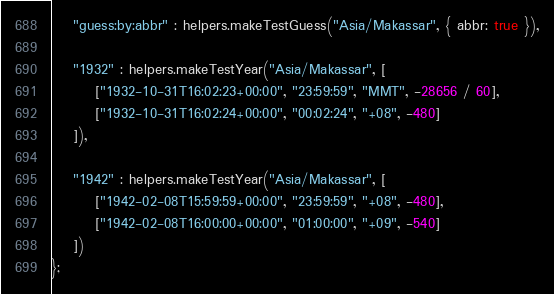<code> <loc_0><loc_0><loc_500><loc_500><_JavaScript_>	"guess:by:abbr" : helpers.makeTestGuess("Asia/Makassar", { abbr: true }),

	"1932" : helpers.makeTestYear("Asia/Makassar", [
		["1932-10-31T16:02:23+00:00", "23:59:59", "MMT", -28656 / 60],
		["1932-10-31T16:02:24+00:00", "00:02:24", "+08", -480]
	]),

	"1942" : helpers.makeTestYear("Asia/Makassar", [
		["1942-02-08T15:59:59+00:00", "23:59:59", "+08", -480],
		["1942-02-08T16:00:00+00:00", "01:00:00", "+09", -540]
	])
};</code> 